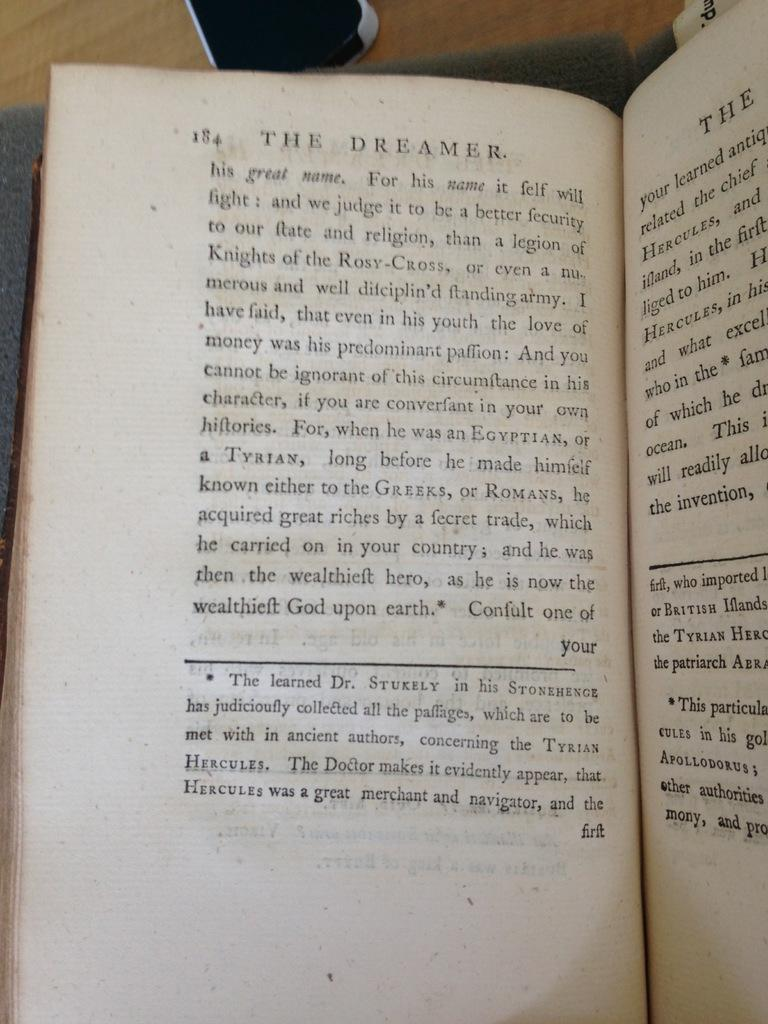<image>
Render a clear and concise summary of the photo. A book opened up to page 18 with the title, The Dreamer, at the top. 